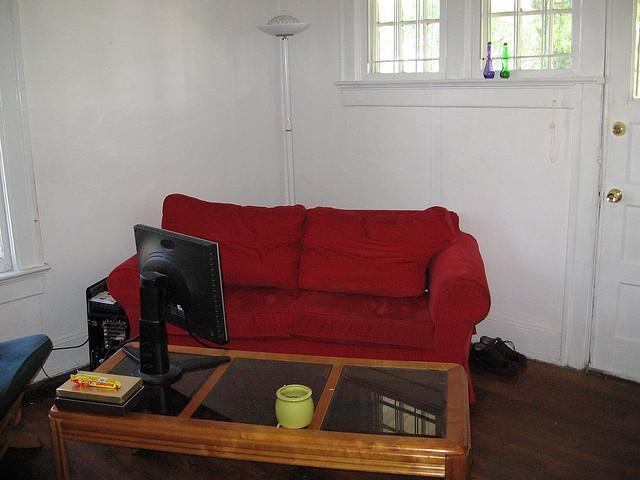How many shoes are by the couch?
Give a very brief answer. 2. How many people are wearing red?
Give a very brief answer. 0. 